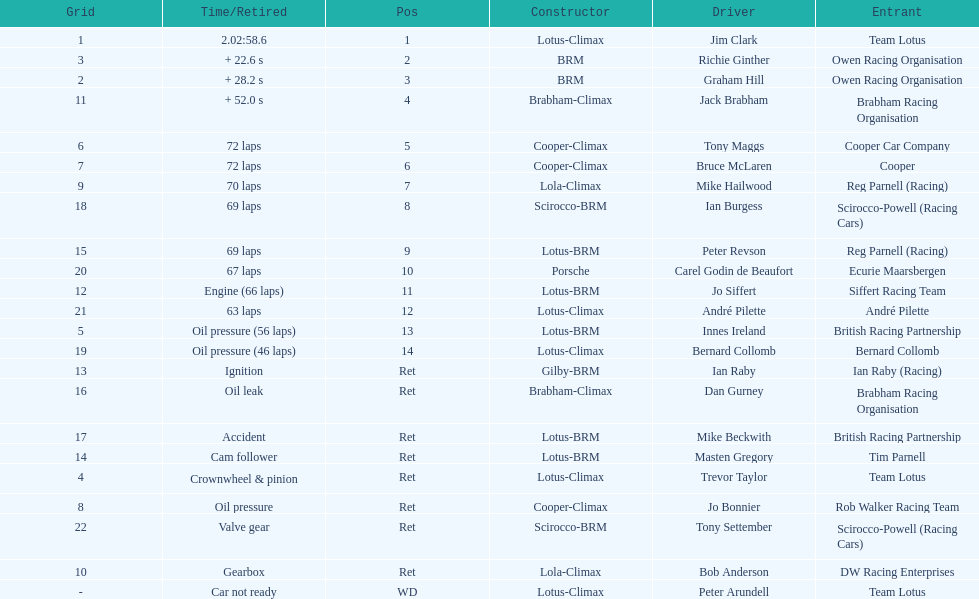What was the same problem that bernard collomb had as innes ireland? Oil pressure. 